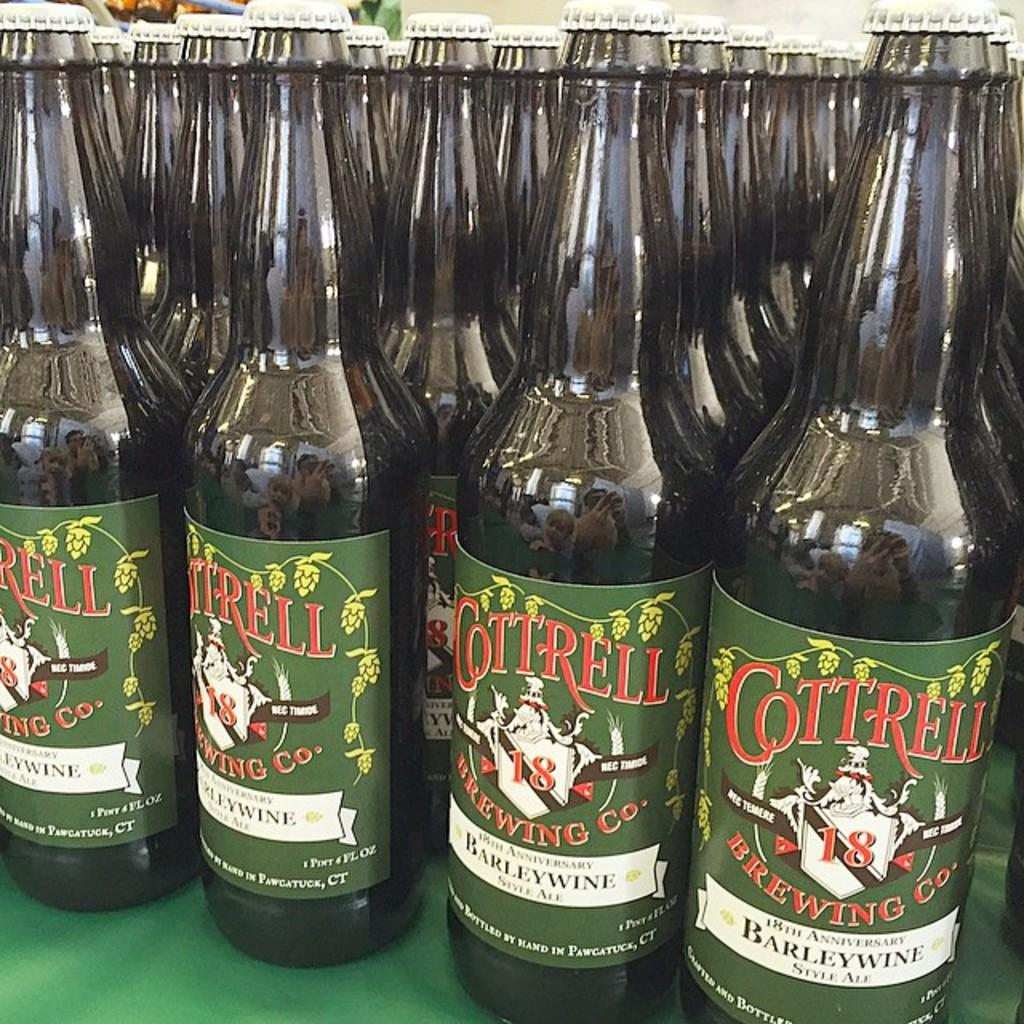<image>
Give a short and clear explanation of the subsequent image. the word cottrell is on some of the bottles 